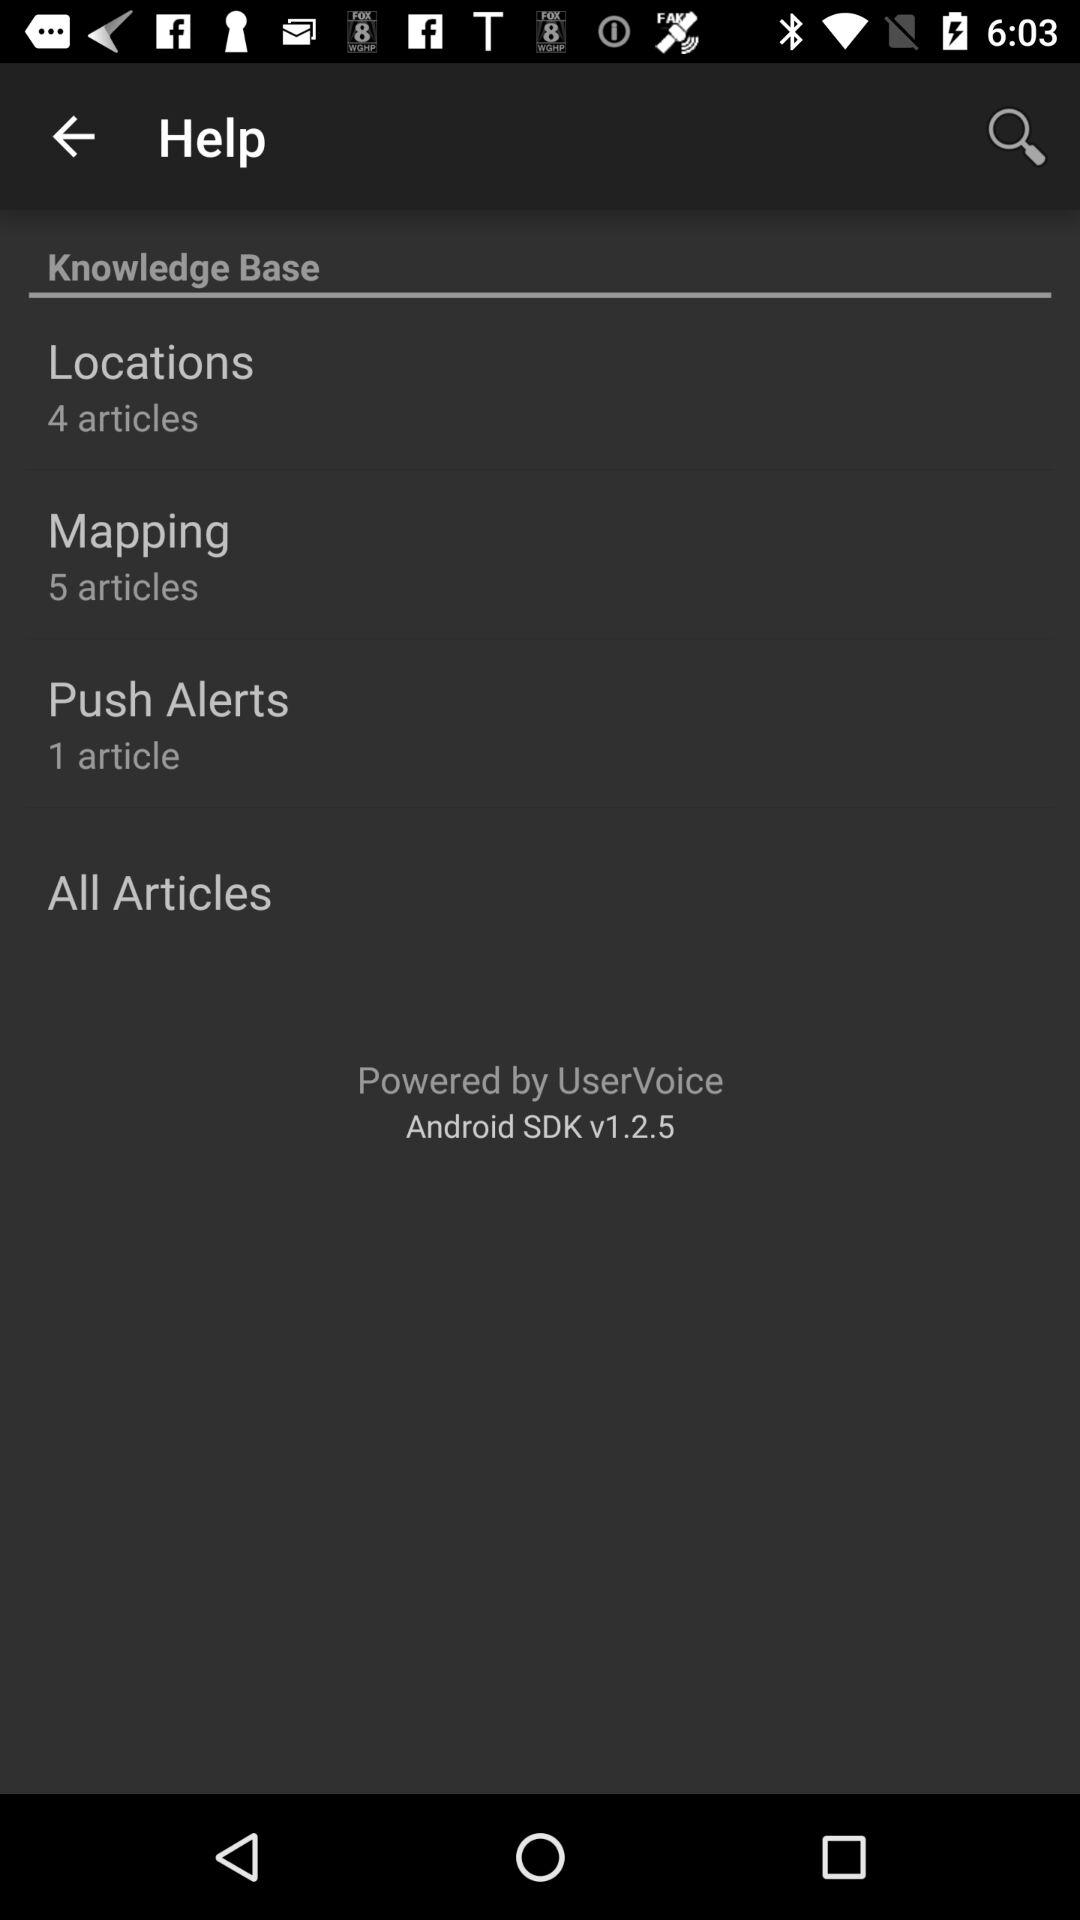How many more articles are there in the Mapping category than the Push Alerts category?
Answer the question using a single word or phrase. 4 